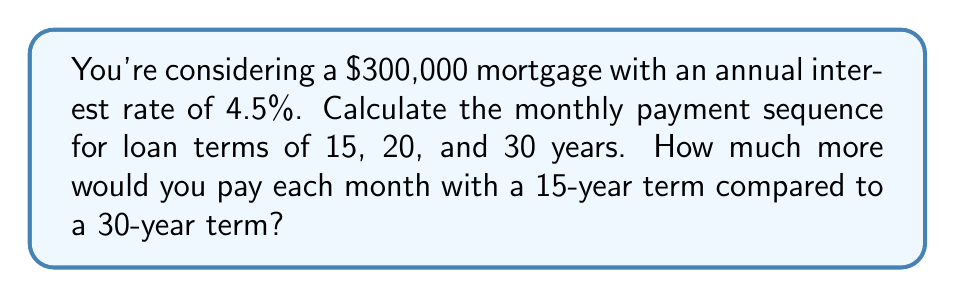Give your solution to this math problem. To calculate the monthly mortgage payment, we'll use the formula:

$$ P = L \frac{r(1+r)^n}{(1+r)^n - 1} $$

Where:
$P$ = monthly payment
$L$ = loan amount
$r$ = monthly interest rate (annual rate divided by 12)
$n$ = total number of months

Step 1: Calculate the monthly interest rate
$r = 0.045 / 12 = 0.00375$

Step 2: Calculate monthly payments for each term
For 15 years (180 months):
$$ P_{15} = 300000 \frac{0.00375(1+0.00375)^{180}}{(1+0.00375)^{180} - 1} = 2295.71 $$

For 20 years (240 months):
$$ P_{20} = 300000 \frac{0.00375(1+0.00375)^{240}}{(1+0.00375)^{240} - 1} = 1897.95 $$

For 30 years (360 months):
$$ P_{30} = 300000 \frac{0.00375(1+0.00375)^{360}}{(1+0.00375)^{360} - 1} = 1520.06 $$

Step 3: Calculate the difference between 15-year and 30-year monthly payments
$$ 2295.71 - 1520.06 = 775.65 $$

The sequence of monthly payments for 15, 20, and 30-year terms is:
$2295.71, 1897.95, 1520.06$

You would pay $775.65 more each month with a 15-year term compared to a 30-year term.
Answer: $775.65 